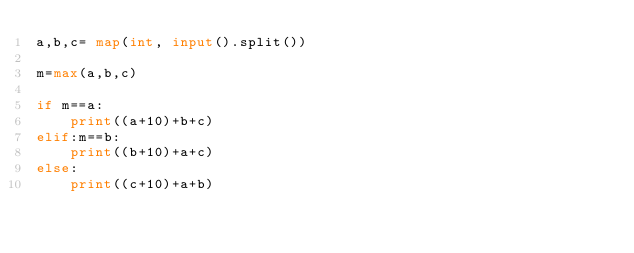Convert code to text. <code><loc_0><loc_0><loc_500><loc_500><_Python_>a,b,c= map(int, input().split())

m=max(a,b,c)

if m==a:
    print((a+10)+b+c)
elif:m==b:
    print((b+10)+a+c)
else:
    print((c+10)+a+b)</code> 